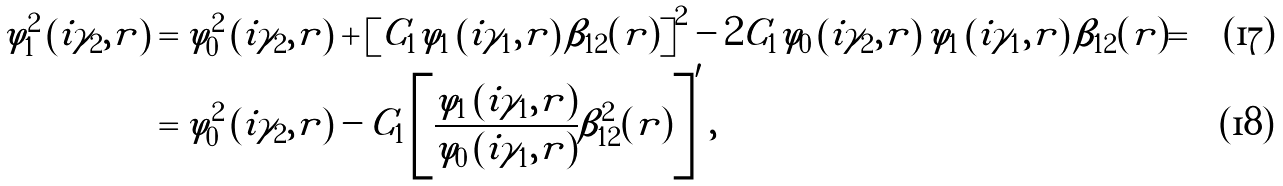<formula> <loc_0><loc_0><loc_500><loc_500>\varphi _ { 1 } ^ { 2 } \left ( i \gamma _ { 2 } , r \right ) & = \varphi _ { 0 } ^ { 2 } \left ( i \gamma _ { 2 } , r \right ) + \left [ C _ { 1 } \varphi _ { 1 } \left ( i \gamma _ { 1 } , r \right ) \beta _ { 1 2 } ( r ) \right ] ^ { 2 } - 2 C _ { 1 } \varphi _ { 0 } \left ( i \gamma _ { 2 } , r \right ) \varphi _ { 1 } \left ( i \gamma _ { 1 } , r \right ) \beta _ { 1 2 } ( r ) = \\ & = \varphi _ { 0 } ^ { 2 } \left ( i \gamma _ { 2 } , r \right ) - C _ { 1 } \left [ \frac { \varphi _ { 1 } \left ( i \gamma _ { 1 } , r \right ) } { \varphi _ { 0 } \left ( i \gamma _ { 1 } , r \right ) } \beta _ { 1 2 } ^ { 2 } ( r ) \right ] ^ { \prime } ,</formula> 